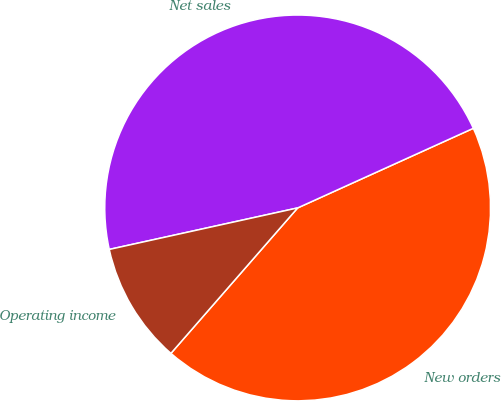Convert chart to OTSL. <chart><loc_0><loc_0><loc_500><loc_500><pie_chart><fcel>New orders<fcel>Net sales<fcel>Operating income<nl><fcel>43.18%<fcel>46.68%<fcel>10.14%<nl></chart> 